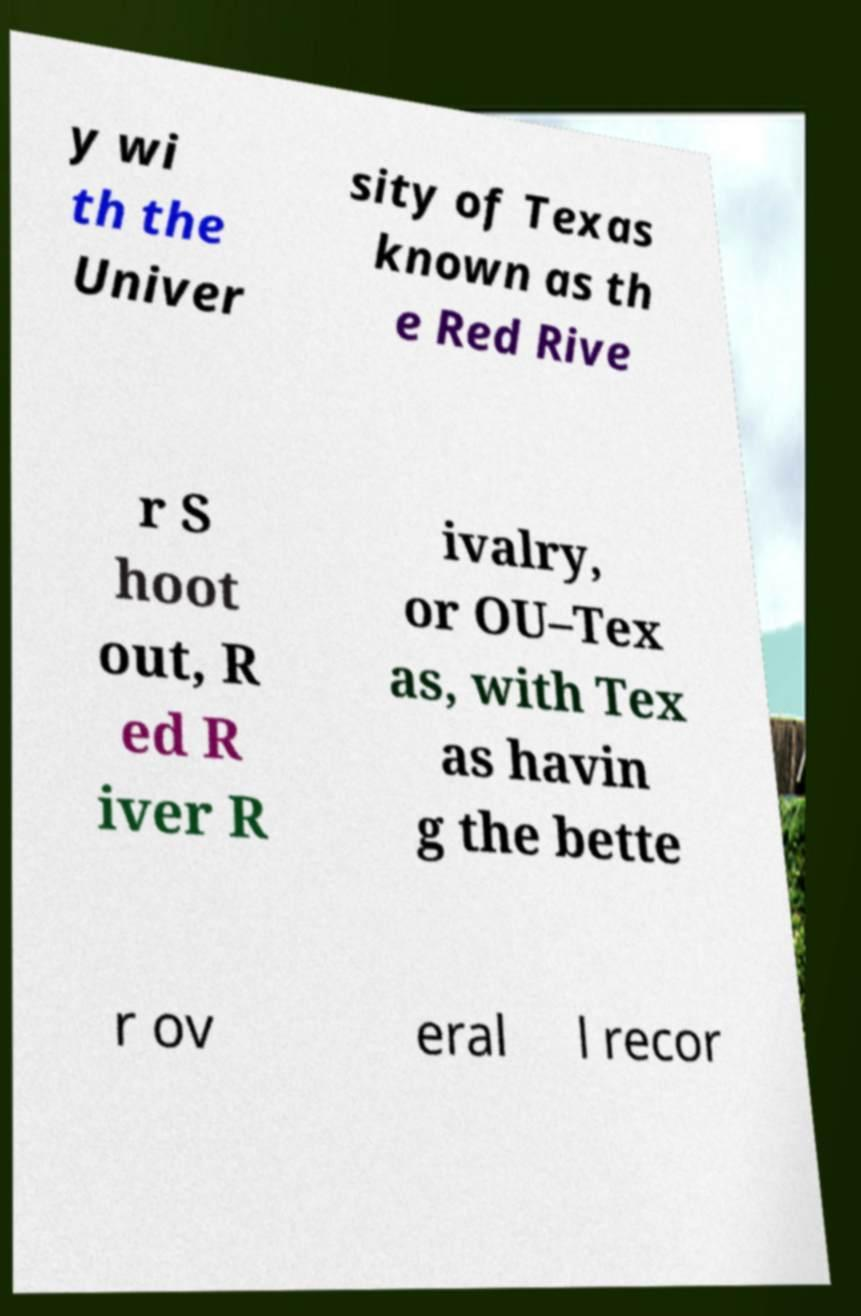Could you extract and type out the text from this image? y wi th the Univer sity of Texas known as th e Red Rive r S hoot out, R ed R iver R ivalry, or OU–Tex as, with Tex as havin g the bette r ov eral l recor 